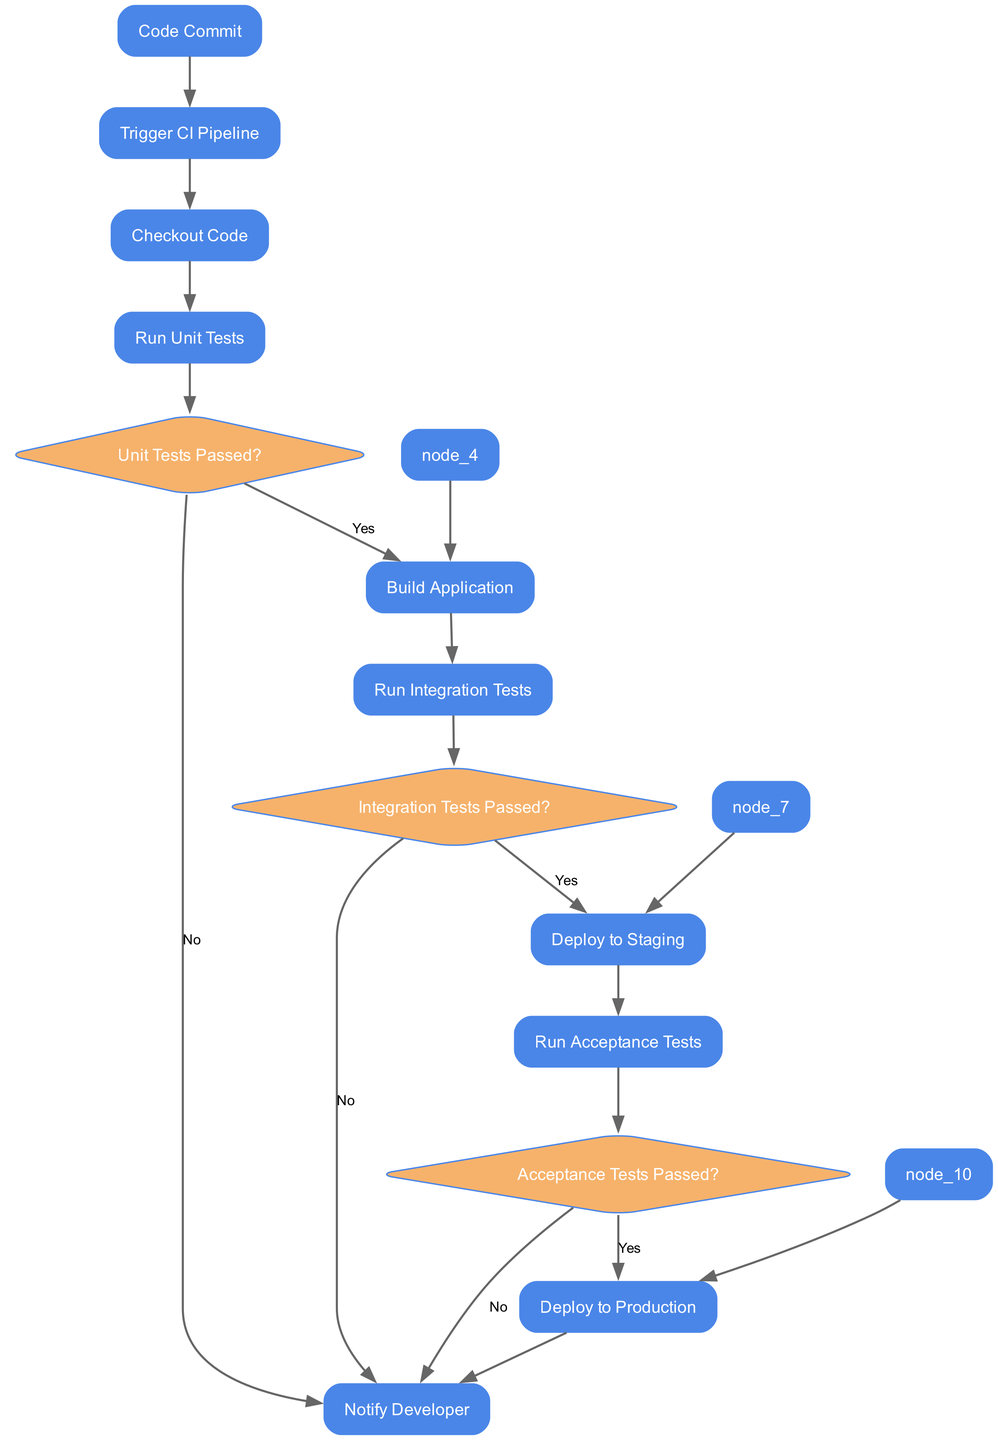What is the first activity in the pipeline? The first activity in the diagram is "Code Commit," which signifies the start of the CI/CD process when a developer commits code.
Answer: Code Commit How many decision points are present in the diagram? The diagram contains three decision points: "Unit Tests Passed?", "Integration Tests Passed?", and "Acceptance Tests Passed?".
Answer: 3 What happens if the unit tests fail? If the unit tests fail, the next action is to "Notify Developer" as indicated in the branches of the decision point for unit tests.
Answer: Notify Developer What activity occurs after the "Deploy to Staging"? After "Deploy to Staging," the next activity is "Run Acceptance Tests," which involves validating the application against requirements.
Answer: Run Acceptance Tests If the integration tests pass, what is the next step? If the integration tests pass, the next step in the pipeline is "Deploy to Staging," where the application is deployed for further testing.
Answer: Deploy to Staging What activity comes before "Deploy to Production"? The activity that comes directly before "Deploy to Production" is "Run Acceptance Tests," as it is essential to validate the application before deploying it live.
Answer: Run Acceptance Tests What is the purpose of the "Notify Developer" activity? The purpose of the "Notify Developer" activity is to inform the developer about the pipeline status or errors that may occur during testing phases.
Answer: Notify Developer How many activities are in total, excluding decision points? There are seven activities in total (excluding decision points), which are: "Code Commit," "Trigger CI Pipeline," "Checkout Code," "Run Unit Tests," "Build Application," "Run Integration Tests," and "Deploy to Staging."
Answer: 7 What occurs if acceptance tests fail? If the acceptance tests fail, the next action is to "Notify Developer," alerting them to the failure in the testing phase before proceeding further.
Answer: Notify Developer 